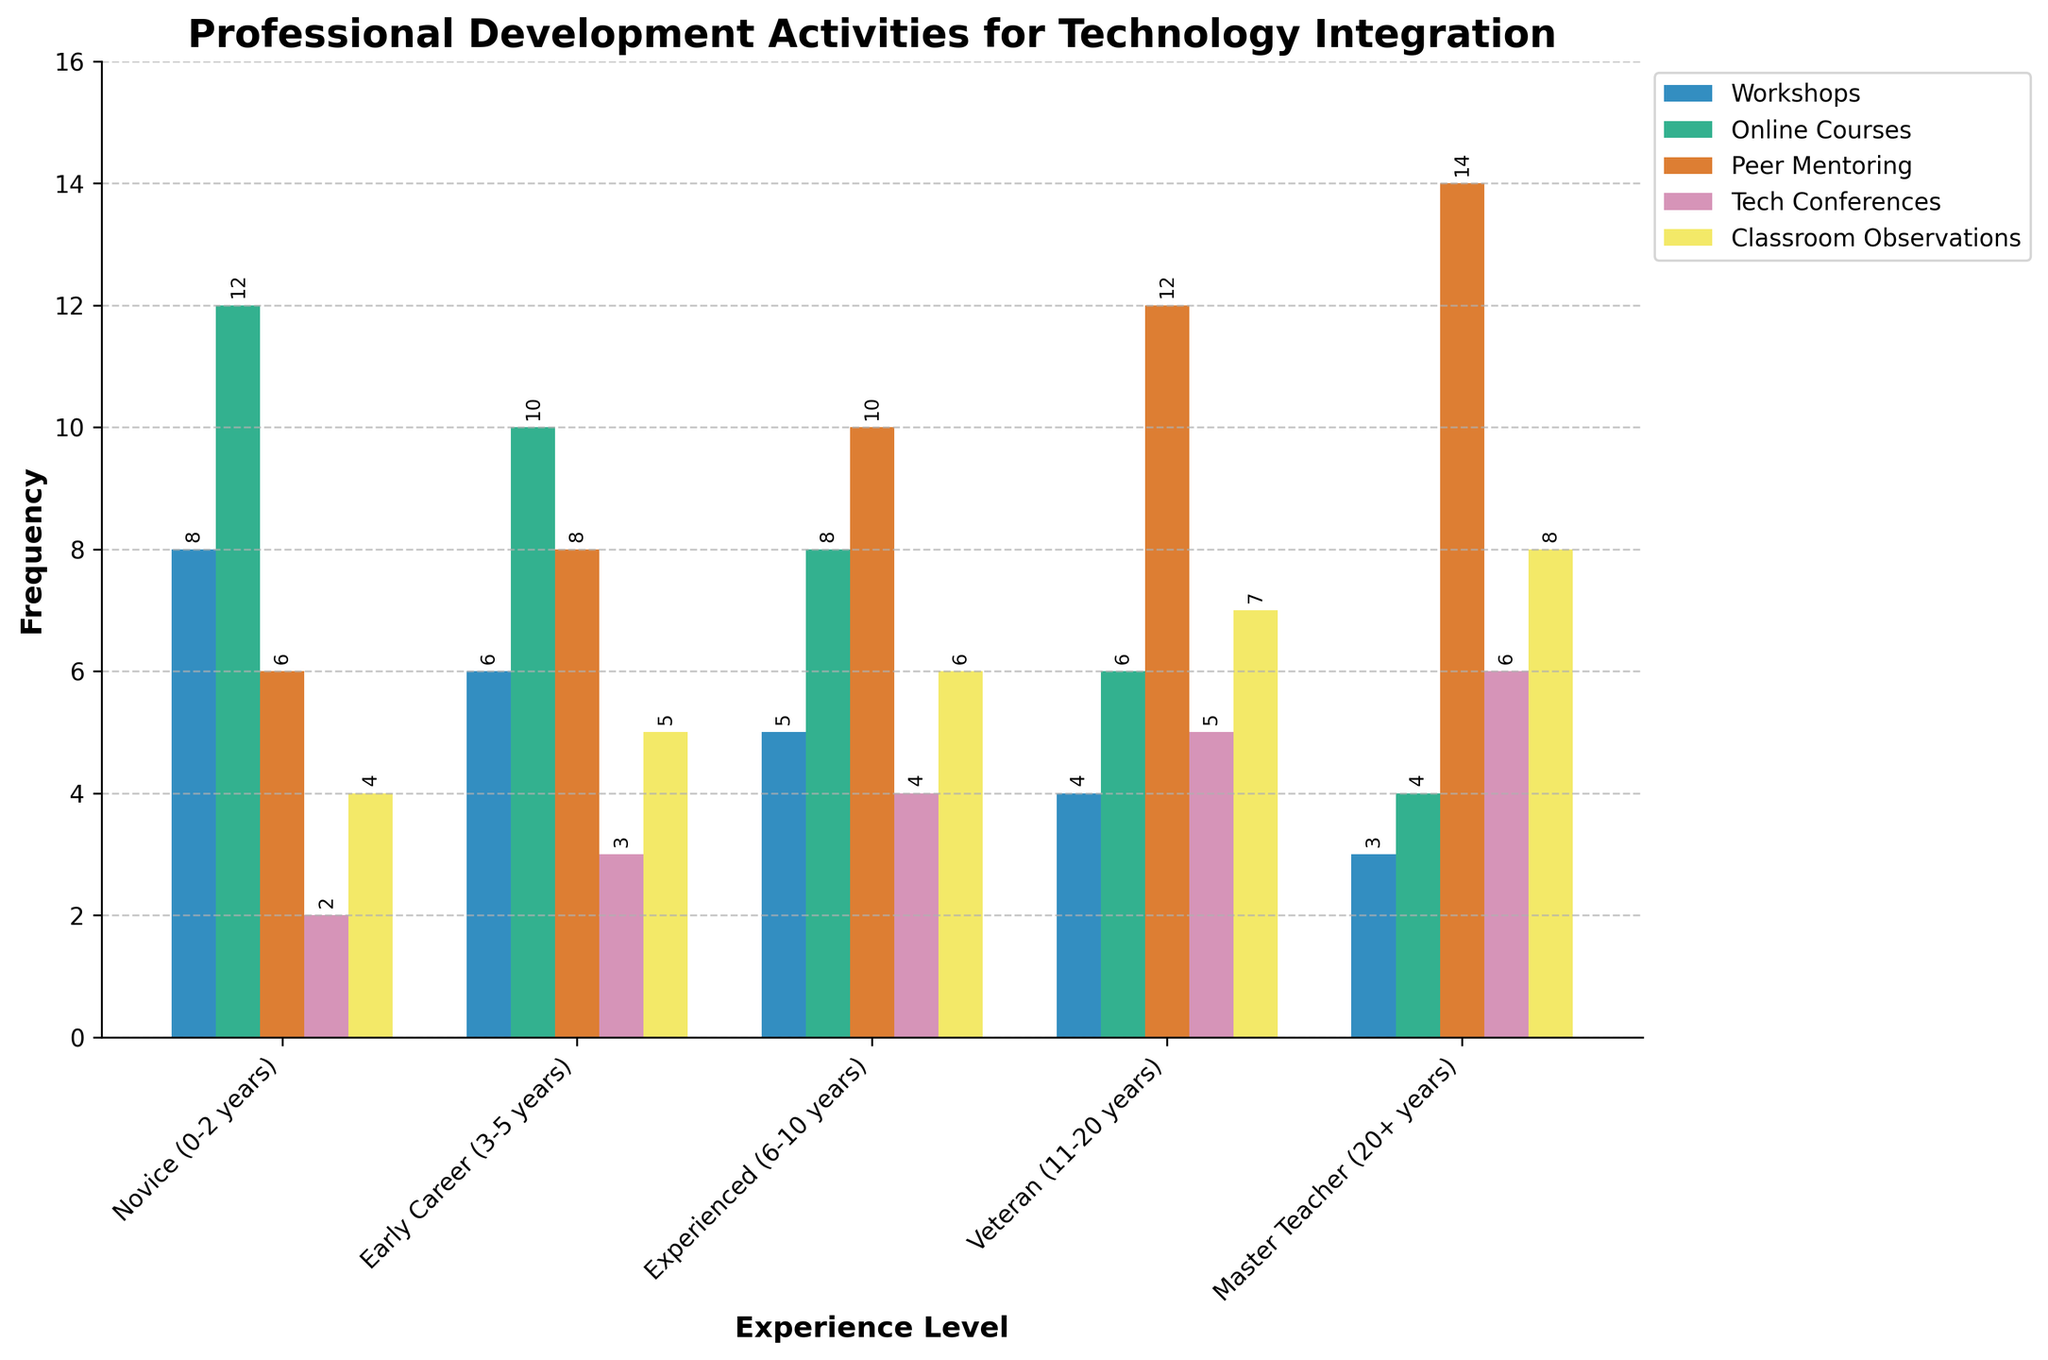Which experience level has the highest frequency of classroom observations? Look at the Classroom Observations bars and identify the one with the tallest height. The Master Teacher (20+ years) bar is the highest.
Answer: Master Teacher (20+ years) Which activity has the highest frequency for Novice (0-2 years) teachers? Observe the heights of the bars for Novice teachers across all activities and find the tallest bar. The Online Courses bar is the tallest.
Answer: Online Courses Compare the total frequency of Peer Mentoring activities for Experienced (6-10 years) and Veteran (11-20 years) teachers. Which one has a higher total? Add the frequencies for Peer Mentoring for Experienced (10) and Veteran (12) teachers. Compare the sums: 10 < 12. Veteran teachers have a higher total.
Answer: Veteran (11-20 years) How many more Workshops do Novice teachers attend compared to Master Teachers? Subtract the frequency of Workshops for Master Teachers (3) from Novice Teachers (8): 8 - 3 = 5.
Answer: 5 Rank the activities for Veteran teachers from highest to lowest frequency. Look at the Veteran teachers' bars: Peer Mentoring (12), Classroom Observations (7), Tech Conferences (5), Online Courses (6), Workshops (4). List from highest to lowest: Peer Mentoring, Classroom Observations, Tech Conferences, Online Courses, Workshops.
Answer: Peer Mentoring, Classroom Observations, Online Courses, Tech Conferences, Workshops What is the average frequency of Tech Conferences attended by all teachers? Sum the frequencies of Tech Conferences for all experience levels: 2 + 3 + 4 + 5 + 6 = 20. Divide this sum by the number of experience levels (5): 20 / 5 = 4.
Answer: 4 Which activity sees the smallest decrease in frequency as teacher experience increases from Novice to Master Teacher? Check the difference between Novice and Master Teacher for each activity: 
- Workshops: 8 - 3 = 5
- Online Courses: 12 - 4 = 8
- Peer Mentoring: 6 - 14 = -8 (increase)
- Tech Conferences: 2 - 6 = -4 (increase)
- Classroom Observations: 4 - 8 = -4 (increase)
Workshops sees the smallest decrease.
Answer: Workshops 